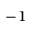Convert formula to latex. <formula><loc_0><loc_0><loc_500><loc_500>^ { - 1 }</formula> 